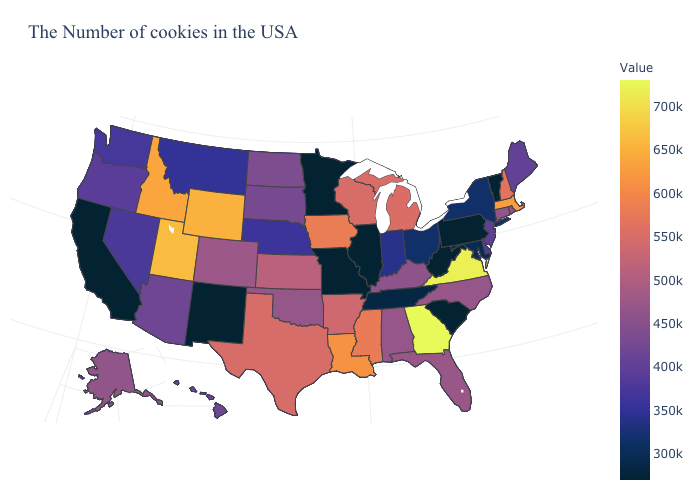Does Nevada have a higher value than South Carolina?
Answer briefly. Yes. Does Pennsylvania have the lowest value in the Northeast?
Answer briefly. Yes. Does Iowa have the highest value in the MidWest?
Write a very short answer. Yes. Does Massachusetts have a lower value than Georgia?
Short answer required. Yes. 